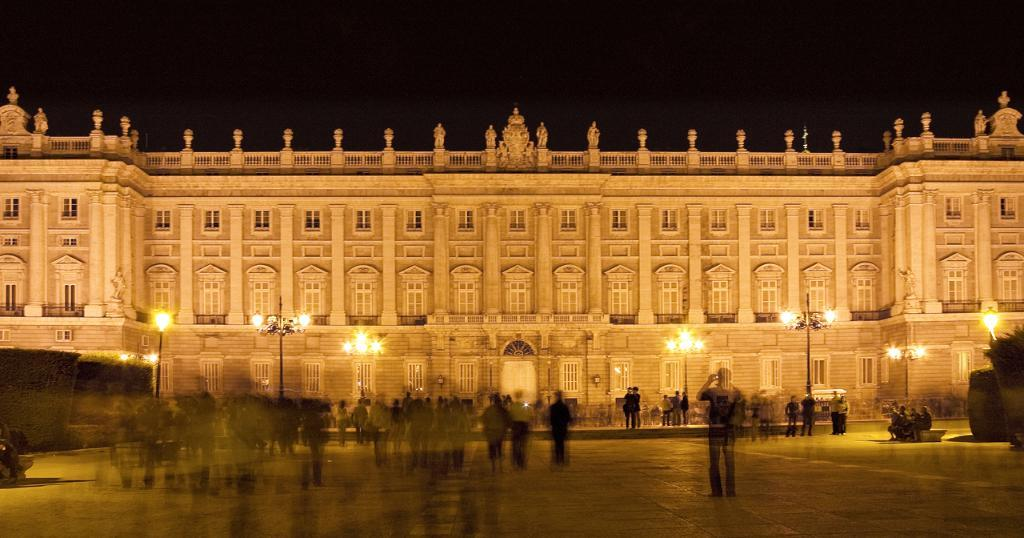What is the main structure in the center of the image? There is a palace in the center of the image. What can be seen at the bottom of the image? There are people at the bottom of the image. What objects are visible in the image besides the palace and people? There are poles visible in the image. What is the condition of the sky in the background of the image? The sky is visible in the background of the image. Where is the shelf located in the image? There is no shelf present in the image. What type of horn can be heard in the image? There is no sound or horn present in the image. 